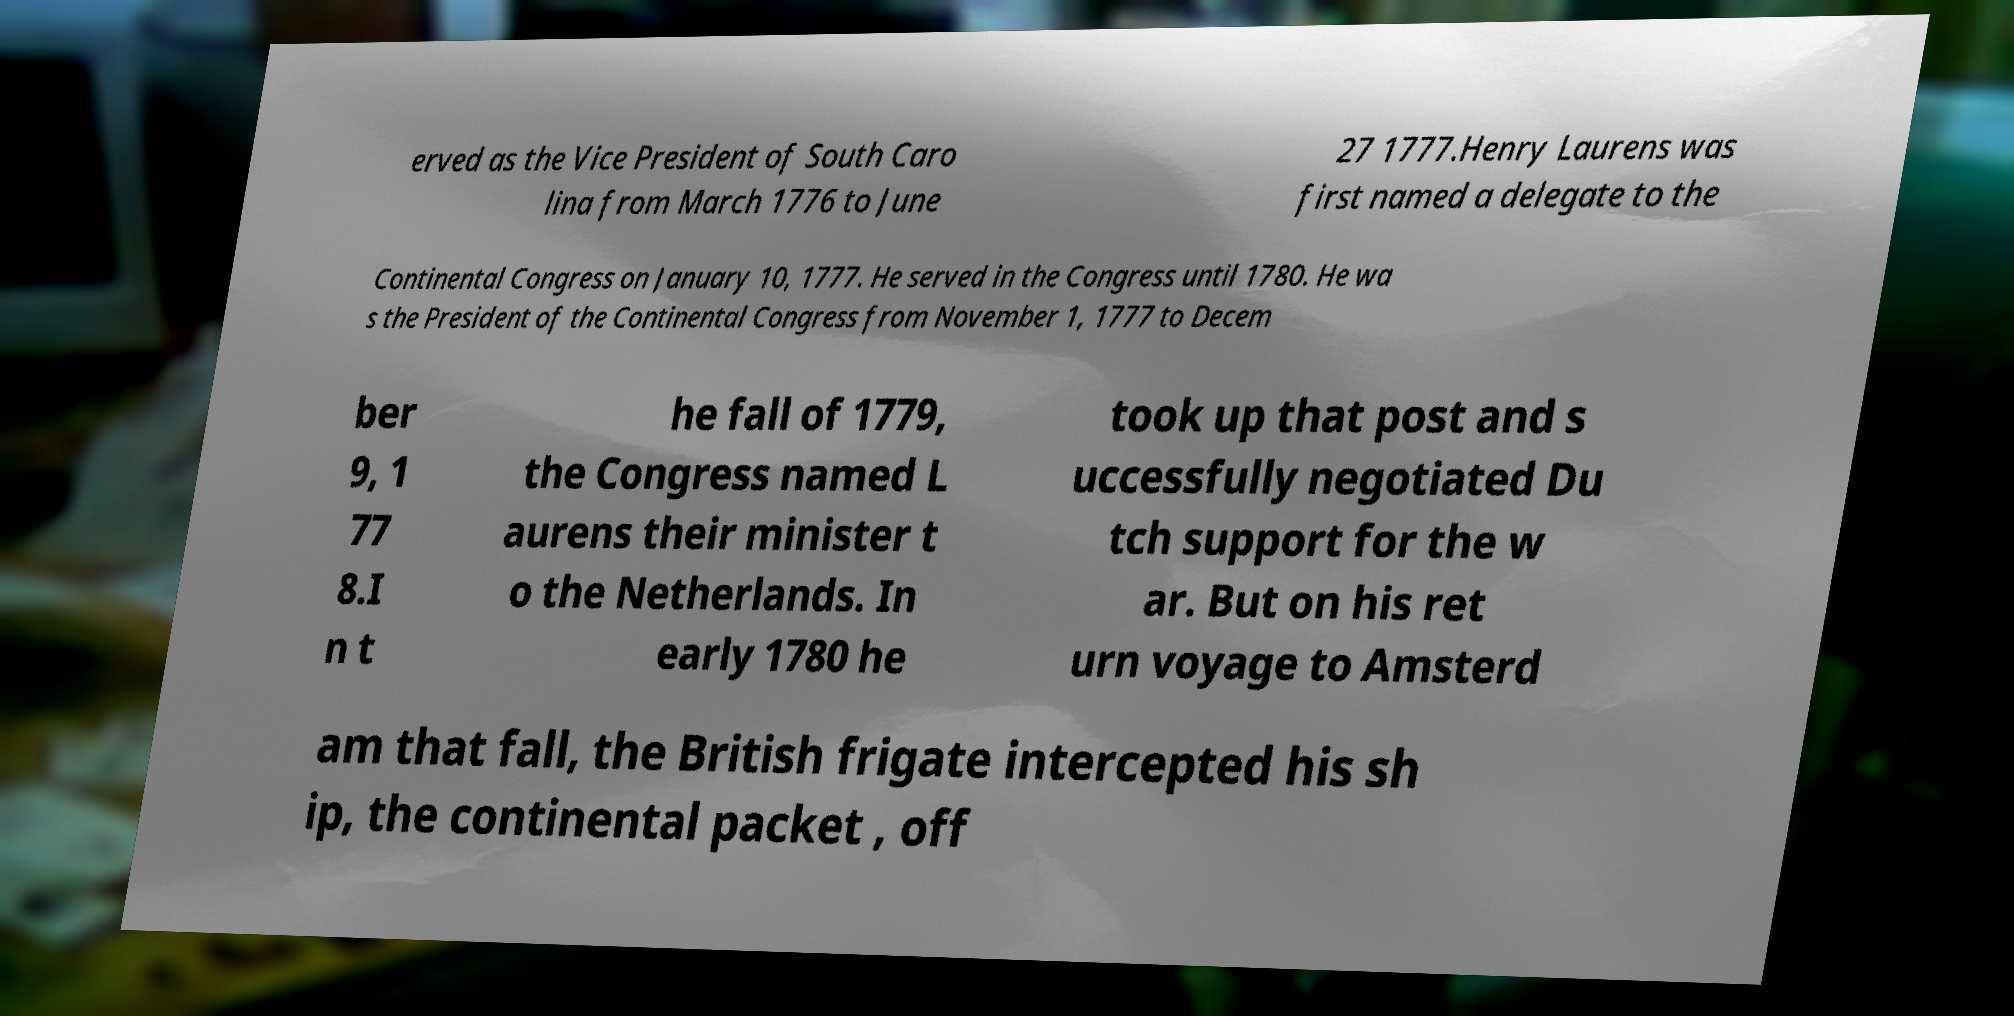What messages or text are displayed in this image? I need them in a readable, typed format. erved as the Vice President of South Caro lina from March 1776 to June 27 1777.Henry Laurens was first named a delegate to the Continental Congress on January 10, 1777. He served in the Congress until 1780. He wa s the President of the Continental Congress from November 1, 1777 to Decem ber 9, 1 77 8.I n t he fall of 1779, the Congress named L aurens their minister t o the Netherlands. In early 1780 he took up that post and s uccessfully negotiated Du tch support for the w ar. But on his ret urn voyage to Amsterd am that fall, the British frigate intercepted his sh ip, the continental packet , off 